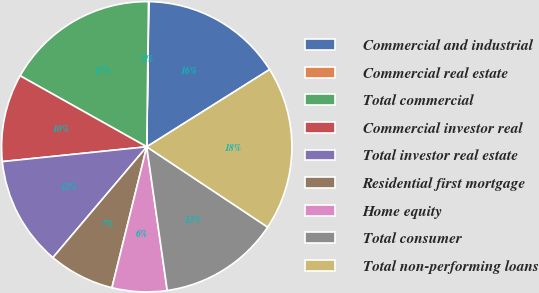<chart> <loc_0><loc_0><loc_500><loc_500><pie_chart><fcel>Commercial and industrial<fcel>Commercial real estate<fcel>Total commercial<fcel>Commercial investor real<fcel>Total investor real estate<fcel>Residential first mortgage<fcel>Home equity<fcel>Total consumer<fcel>Total non-performing loans<nl><fcel>15.84%<fcel>0.03%<fcel>17.06%<fcel>9.76%<fcel>12.19%<fcel>7.33%<fcel>6.11%<fcel>13.41%<fcel>18.27%<nl></chart> 